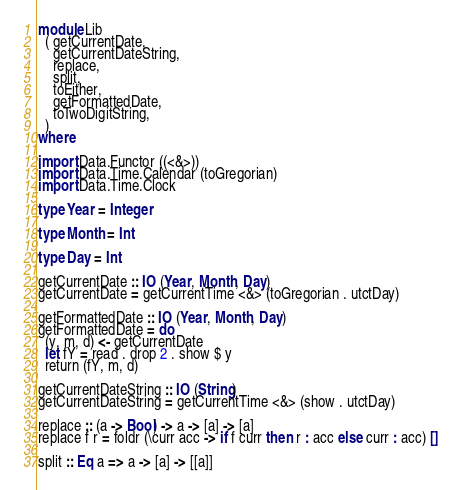<code> <loc_0><loc_0><loc_500><loc_500><_Haskell_>module Lib
  ( getCurrentDate,
    getCurrentDateString,
    replace,
    split,
    toEither,
    getFormattedDate,
    toTwoDigitString,
  )
where

import Data.Functor ((<&>))
import Data.Time.Calendar (toGregorian)
import Data.Time.Clock

type Year = Integer

type Month = Int

type Day = Int

getCurrentDate :: IO (Year, Month, Day)
getCurrentDate = getCurrentTime <&> (toGregorian . utctDay)

getFormattedDate :: IO (Year, Month, Day)
getFormattedDate = do
  (y, m, d) <- getCurrentDate
  let fY = read . drop 2 . show $ y
  return (fY, m, d)

getCurrentDateString :: IO (String)
getCurrentDateString = getCurrentTime <&> (show . utctDay)

replace :: (a -> Bool) -> a -> [a] -> [a]
replace f r = foldr (\curr acc -> if f curr then r : acc else curr : acc) []

split :: Eq a => a -> [a] -> [[a]]</code> 